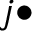<formula> <loc_0><loc_0><loc_500><loc_500>j \bullet</formula> 